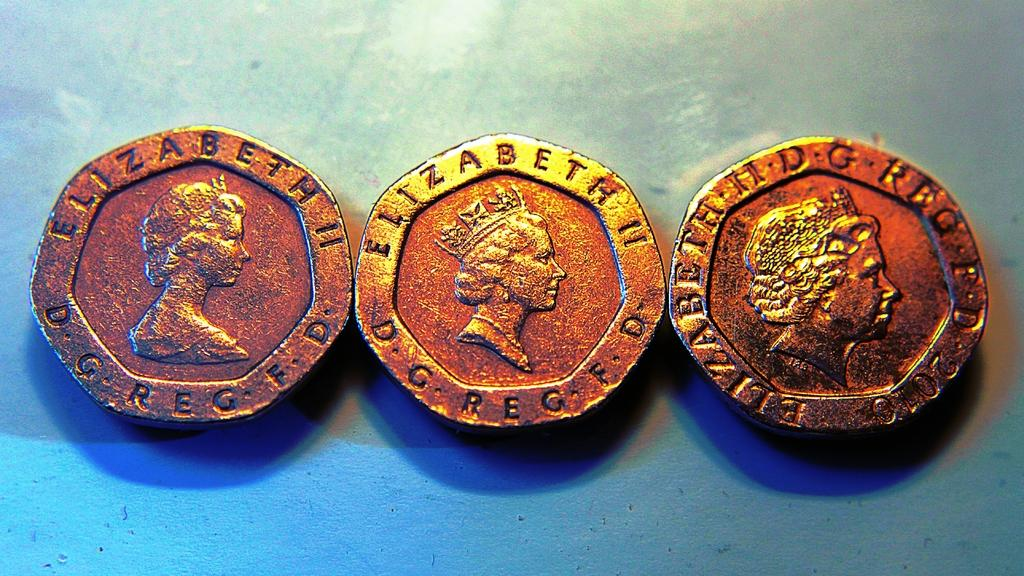Provide a one-sentence caption for the provided image. Antique coins embellished with the name Elizabeth II lay next to each other. 